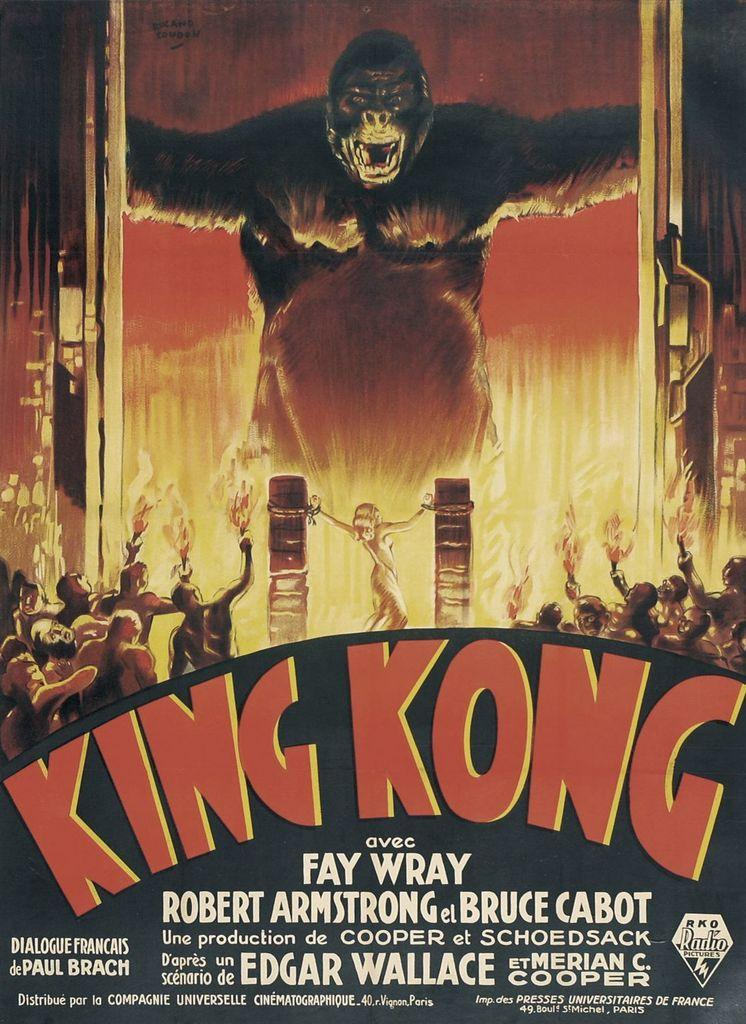<image>
Write a terse but informative summary of the picture. King Kong movie advertisement directed by Fay Wray 